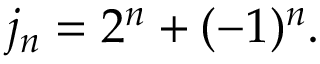Convert formula to latex. <formula><loc_0><loc_0><loc_500><loc_500>j _ { n } = 2 ^ { n } + ( - 1 ) ^ { n } .</formula> 